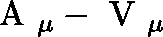<formula> <loc_0><loc_0><loc_500><loc_500>\boldmath A _ { \mu } - \boldmath V _ { \mu }</formula> 